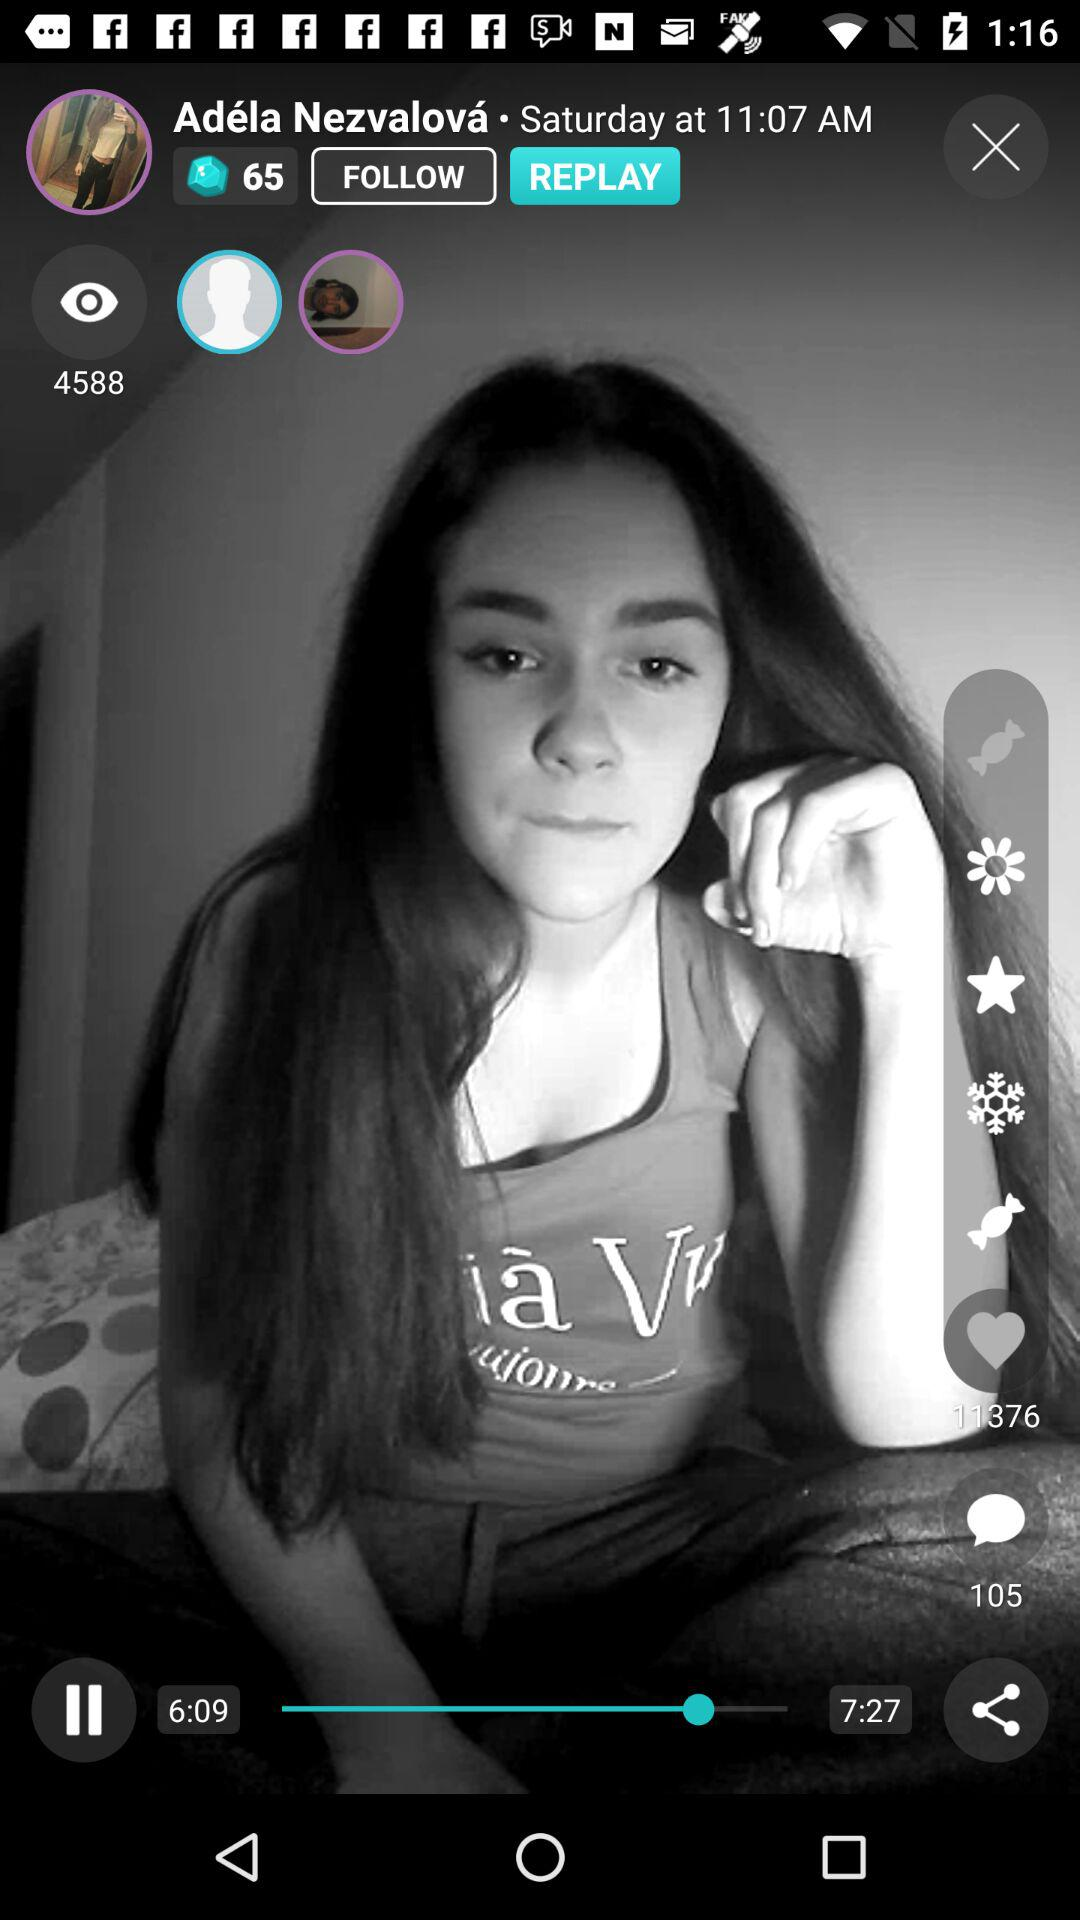What is the duration of the video? The duration is 7 minutes and 27 seconds. 